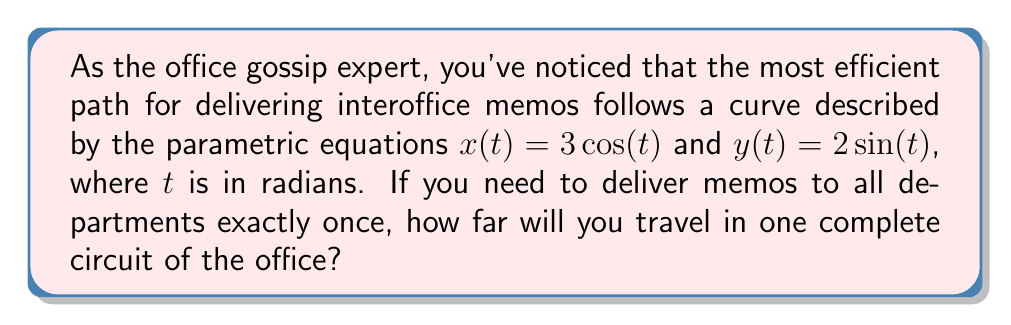Give your solution to this math problem. To solve this problem, we need to calculate the length of the parametric curve for one complete circuit. The formula for the arc length of a parametric curve is:

$$L = \int_{a}^{b} \sqrt{\left(\frac{dx}{dt}\right)^2 + \left(\frac{dy}{dt}\right)^2} dt$$

Where $a$ and $b$ are the start and end values of the parameter $t$.

Steps:
1) First, we need to find $\frac{dx}{dt}$ and $\frac{dy}{dt}$:
   $\frac{dx}{dt} = -3\sin(t)$
   $\frac{dy}{dt} = 2\cos(t)$

2) Substitute these into the arc length formula:
   $$L = \int_{0}^{2\pi} \sqrt{(-3\sin(t))^2 + (2\cos(t))^2} dt$$

3) Simplify under the square root:
   $$L = \int_{0}^{2\pi} \sqrt{9\sin^2(t) + 4\cos^2(t)} dt$$

4) Factor out the common term:
   $$L = \int_{0}^{2\pi} \sqrt{9(\sin^2(t) + \frac{4}{9}\cos^2(t))} dt$$
   $$L = 3\int_{0}^{2\pi} \sqrt{\sin^2(t) + \frac{4}{9}\cos^2(t)} dt$$

5) The expression under the square root is constant and equal to 1:
   $\sin^2(t) + \frac{4}{9}\cos^2(t) = \sin^2(t) + \cos^2(t) - \frac{5}{9}\cos^2(t) = 1 - \frac{5}{9}\cos^2(t)$
   
   The maximum value of $\cos^2(t)$ is 1, so the minimum value of this expression is $1 - \frac{5}{9} = \frac{4}{9}$
   The minimum value of $\cos^2(t)$ is 0, so the maximum value of this expression is 1
   
   Therefore, $\sqrt{\sin^2(t) + \frac{4}{9}\cos^2(t)} = 1$ for all $t$

6) The integral simplifies to:
   $$L = 3\int_{0}^{2\pi} 1 dt = 3(2\pi) = 6\pi$$

Thus, the total distance traveled in one complete circuit is $6\pi$ units.
Answer: $6\pi$ units 